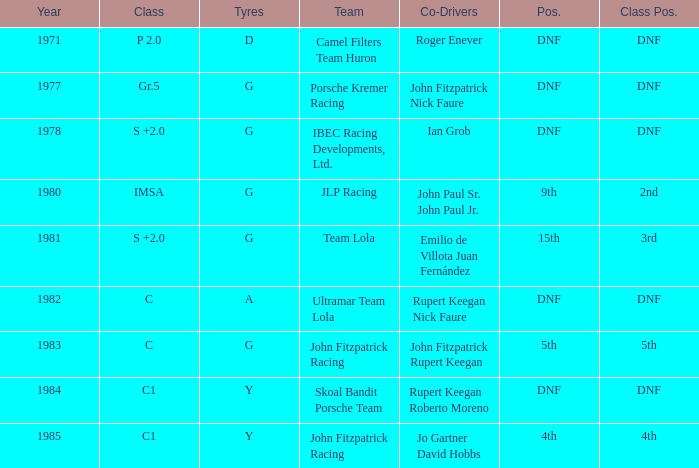Who was the co-driver with a class placement of 2nd? John Paul Sr. John Paul Jr. 